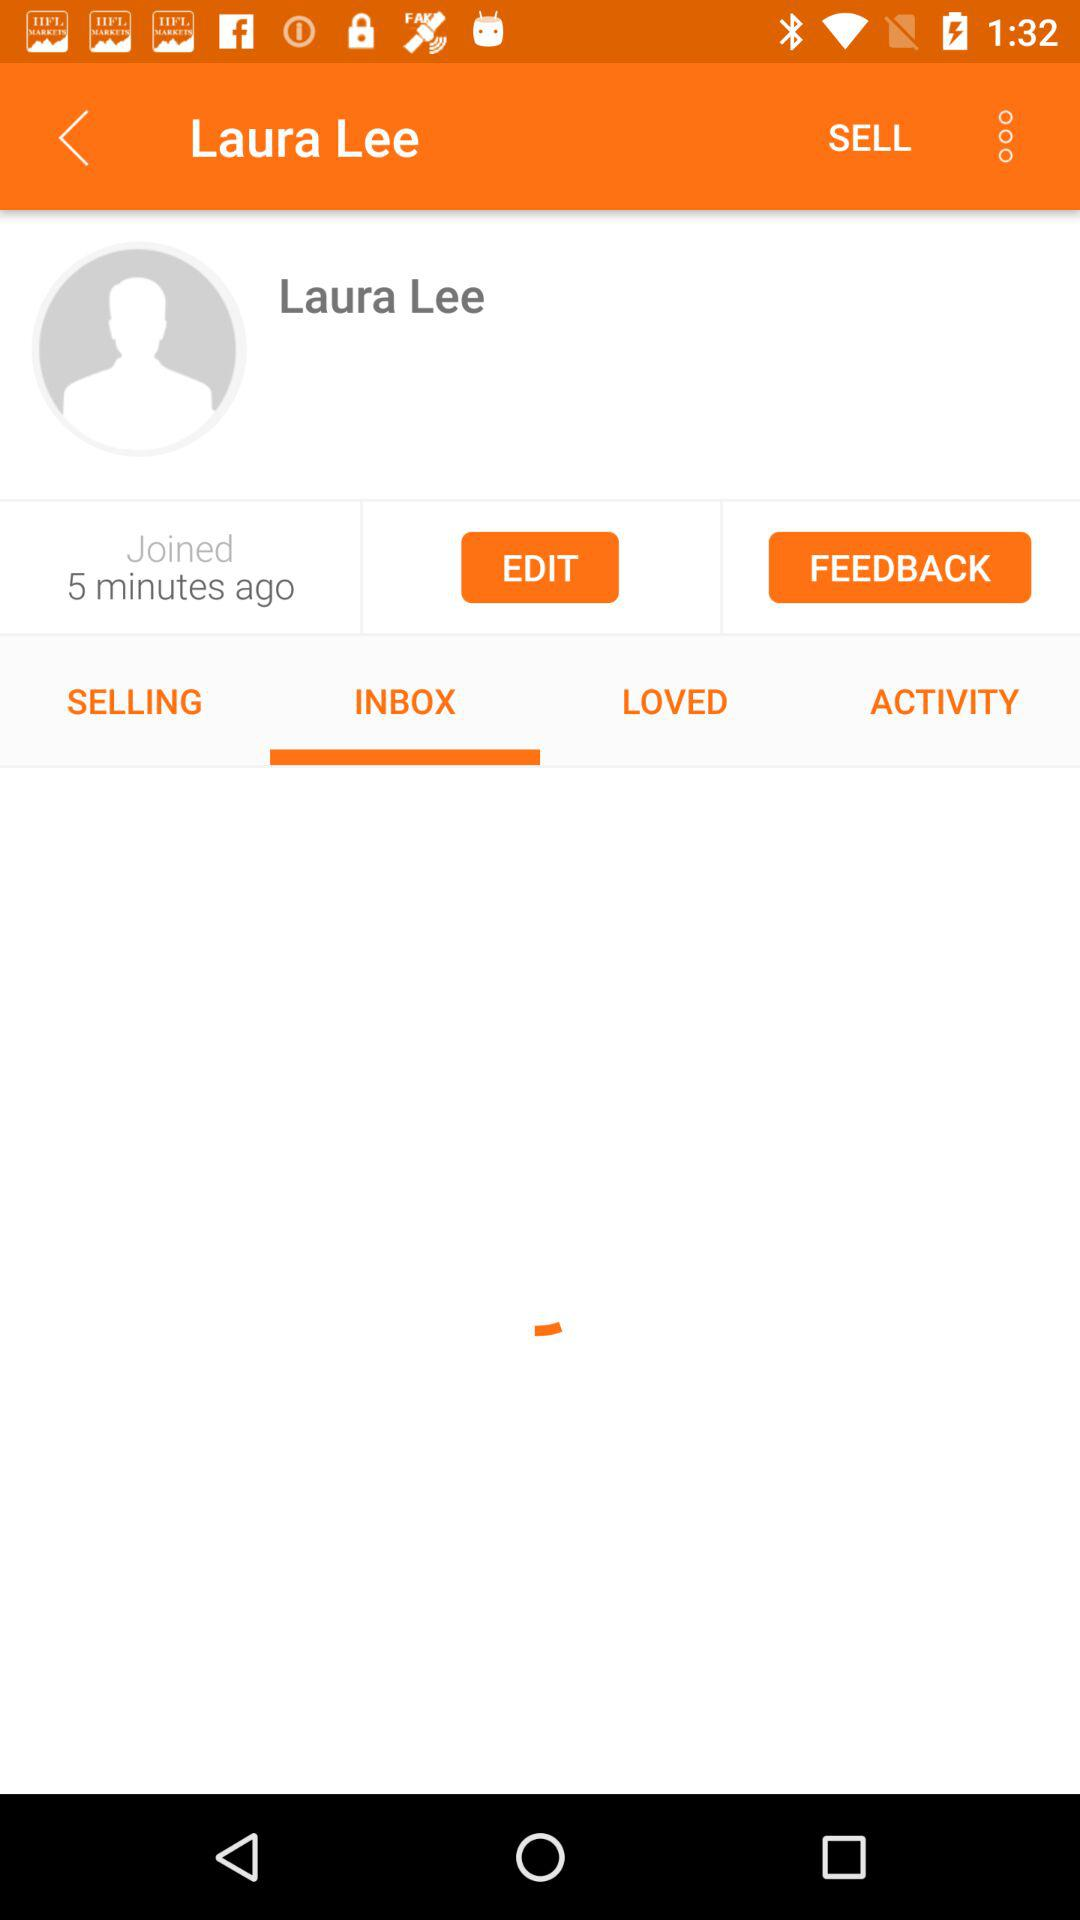What is the user name? The user name is Laura Lee. 